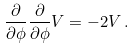<formula> <loc_0><loc_0><loc_500><loc_500>\frac { \partial } { \partial \phi } \frac { \partial } { \partial \phi } V = - 2 V \, .</formula> 